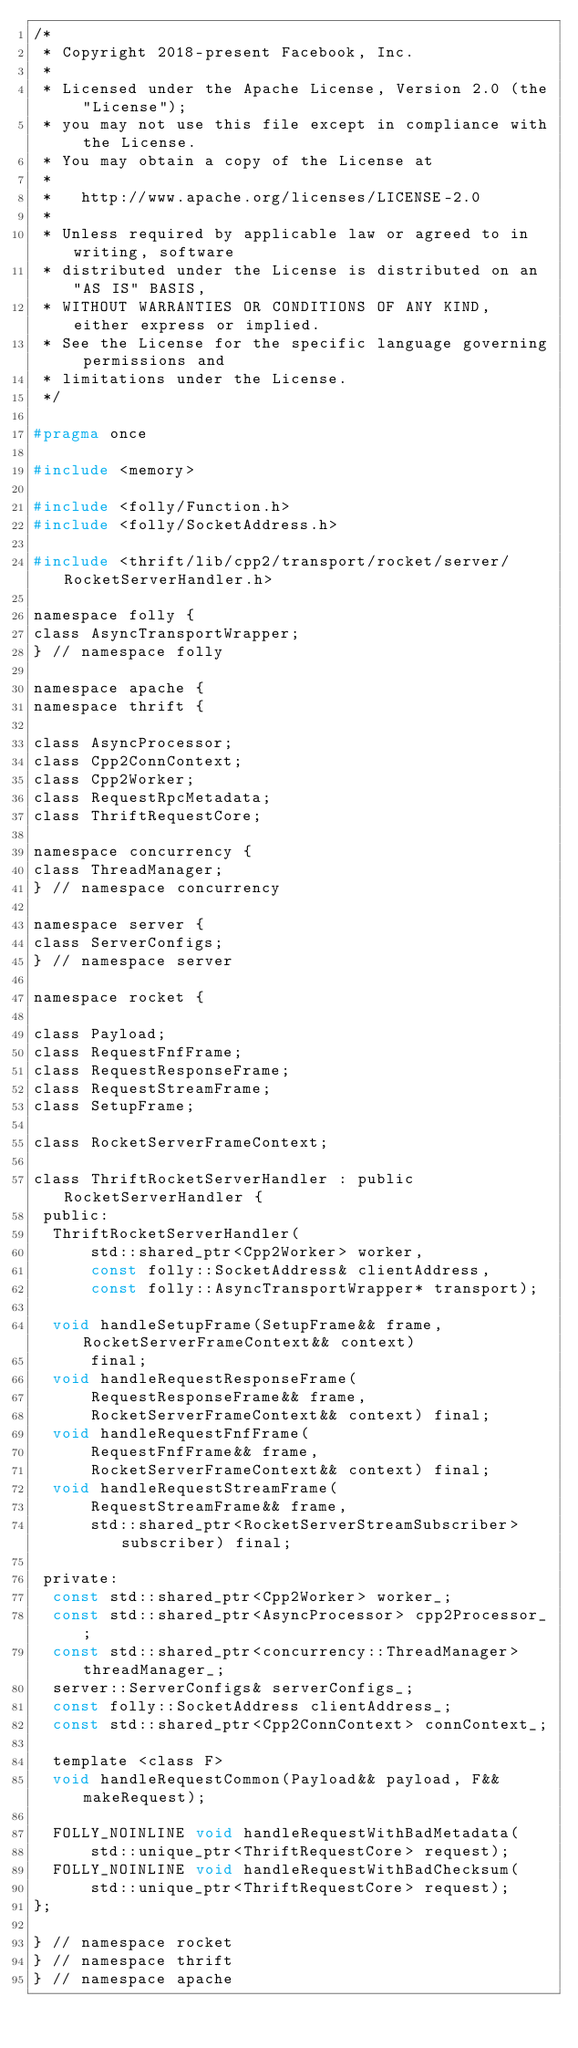<code> <loc_0><loc_0><loc_500><loc_500><_C_>/*
 * Copyright 2018-present Facebook, Inc.
 *
 * Licensed under the Apache License, Version 2.0 (the "License");
 * you may not use this file except in compliance with the License.
 * You may obtain a copy of the License at
 *
 *   http://www.apache.org/licenses/LICENSE-2.0
 *
 * Unless required by applicable law or agreed to in writing, software
 * distributed under the License is distributed on an "AS IS" BASIS,
 * WITHOUT WARRANTIES OR CONDITIONS OF ANY KIND, either express or implied.
 * See the License for the specific language governing permissions and
 * limitations under the License.
 */

#pragma once

#include <memory>

#include <folly/Function.h>
#include <folly/SocketAddress.h>

#include <thrift/lib/cpp2/transport/rocket/server/RocketServerHandler.h>

namespace folly {
class AsyncTransportWrapper;
} // namespace folly

namespace apache {
namespace thrift {

class AsyncProcessor;
class Cpp2ConnContext;
class Cpp2Worker;
class RequestRpcMetadata;
class ThriftRequestCore;

namespace concurrency {
class ThreadManager;
} // namespace concurrency

namespace server {
class ServerConfigs;
} // namespace server

namespace rocket {

class Payload;
class RequestFnfFrame;
class RequestResponseFrame;
class RequestStreamFrame;
class SetupFrame;

class RocketServerFrameContext;

class ThriftRocketServerHandler : public RocketServerHandler {
 public:
  ThriftRocketServerHandler(
      std::shared_ptr<Cpp2Worker> worker,
      const folly::SocketAddress& clientAddress,
      const folly::AsyncTransportWrapper* transport);

  void handleSetupFrame(SetupFrame&& frame, RocketServerFrameContext&& context)
      final;
  void handleRequestResponseFrame(
      RequestResponseFrame&& frame,
      RocketServerFrameContext&& context) final;
  void handleRequestFnfFrame(
      RequestFnfFrame&& frame,
      RocketServerFrameContext&& context) final;
  void handleRequestStreamFrame(
      RequestStreamFrame&& frame,
      std::shared_ptr<RocketServerStreamSubscriber> subscriber) final;

 private:
  const std::shared_ptr<Cpp2Worker> worker_;
  const std::shared_ptr<AsyncProcessor> cpp2Processor_;
  const std::shared_ptr<concurrency::ThreadManager> threadManager_;
  server::ServerConfigs& serverConfigs_;
  const folly::SocketAddress clientAddress_;
  const std::shared_ptr<Cpp2ConnContext> connContext_;

  template <class F>
  void handleRequestCommon(Payload&& payload, F&& makeRequest);

  FOLLY_NOINLINE void handleRequestWithBadMetadata(
      std::unique_ptr<ThriftRequestCore> request);
  FOLLY_NOINLINE void handleRequestWithBadChecksum(
      std::unique_ptr<ThriftRequestCore> request);
};

} // namespace rocket
} // namespace thrift
} // namespace apache
</code> 